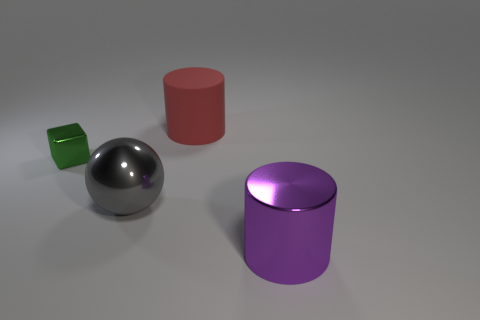Describe the colors present in the image. The image showcases a palette of colors on the metallic objects: there's a shiny gray sphere, a reflective red cylinder on the left, a small green cube, and a larger purple cylinder on the right. The background is a neutral gray, highlighting the colors and shapes of the objects.  How do the shapes of the objects contribute to the composition of the image? The composition includes basic geometric shapes - a sphere, cube, and cylinders - each with distinct colors. These shapes offer a simple yet balanced arrangement, drawing the viewer's eye across the image through their positioning and the contrast of their forms. 